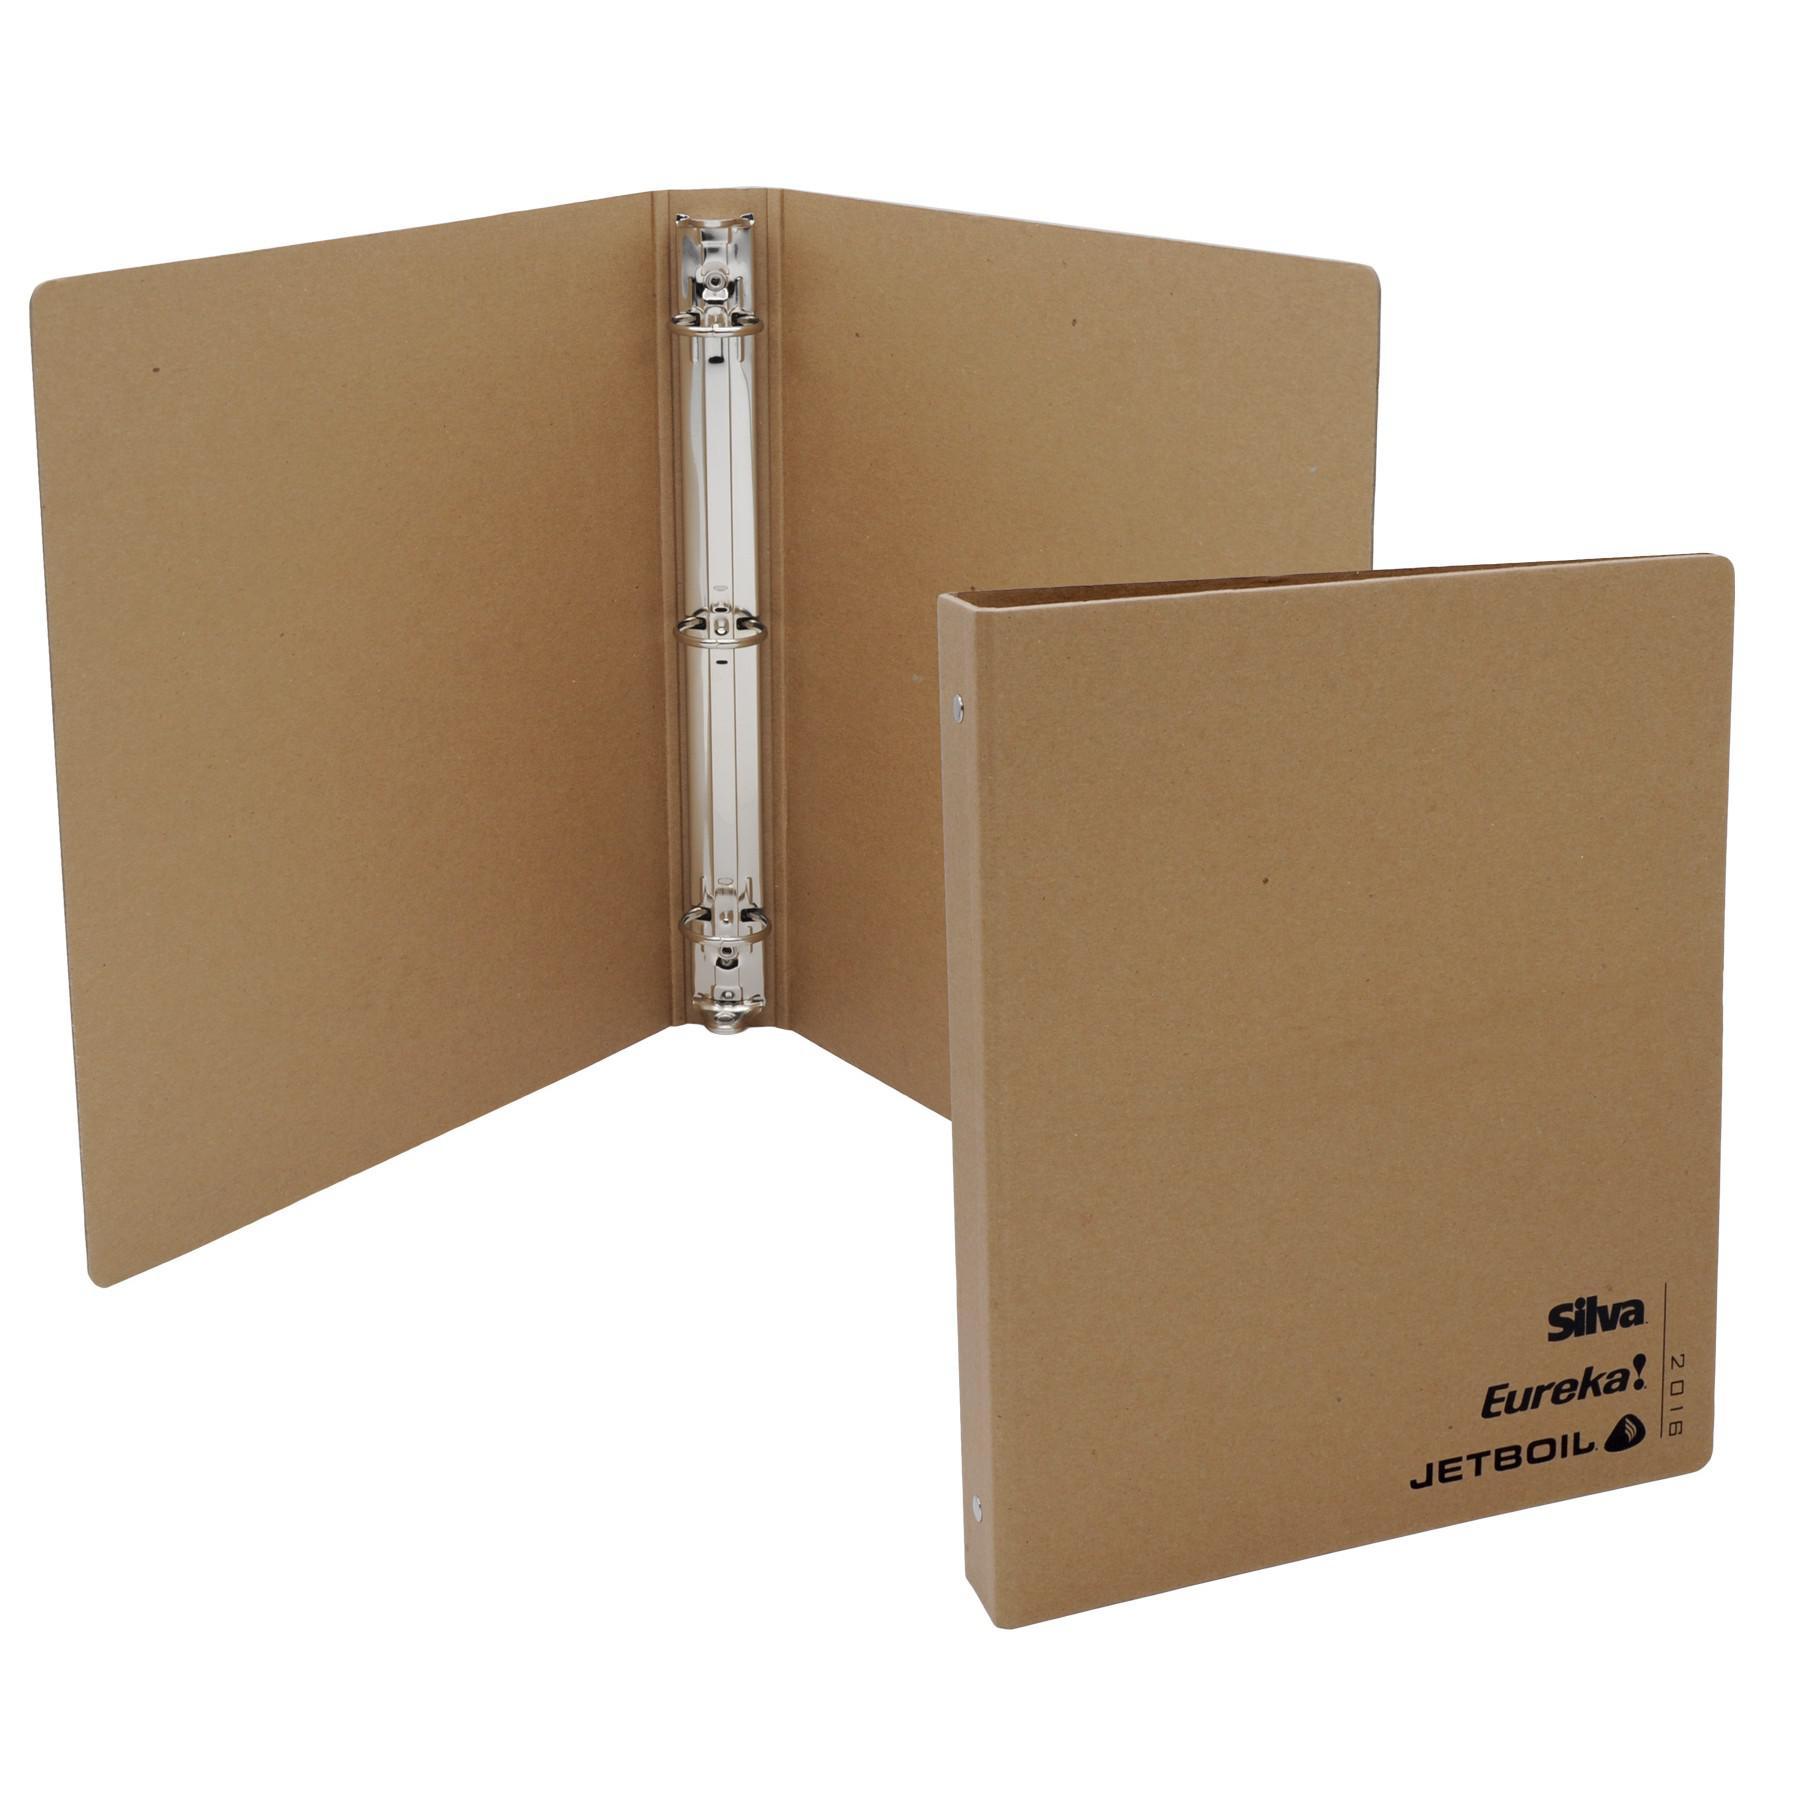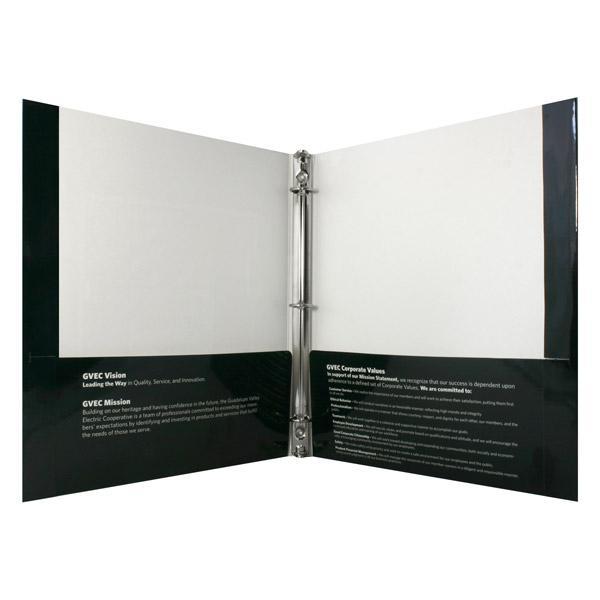The first image is the image on the left, the second image is the image on the right. Evaluate the accuracy of this statement regarding the images: "One image includes at least one closed, upright binder next to an open upright binder, and the combined images contain at least some non-white binders.". Is it true? Answer yes or no. Yes. The first image is the image on the left, the second image is the image on the right. Assess this claim about the two images: "There are no more than two binders shown.". Correct or not? Answer yes or no. No. 